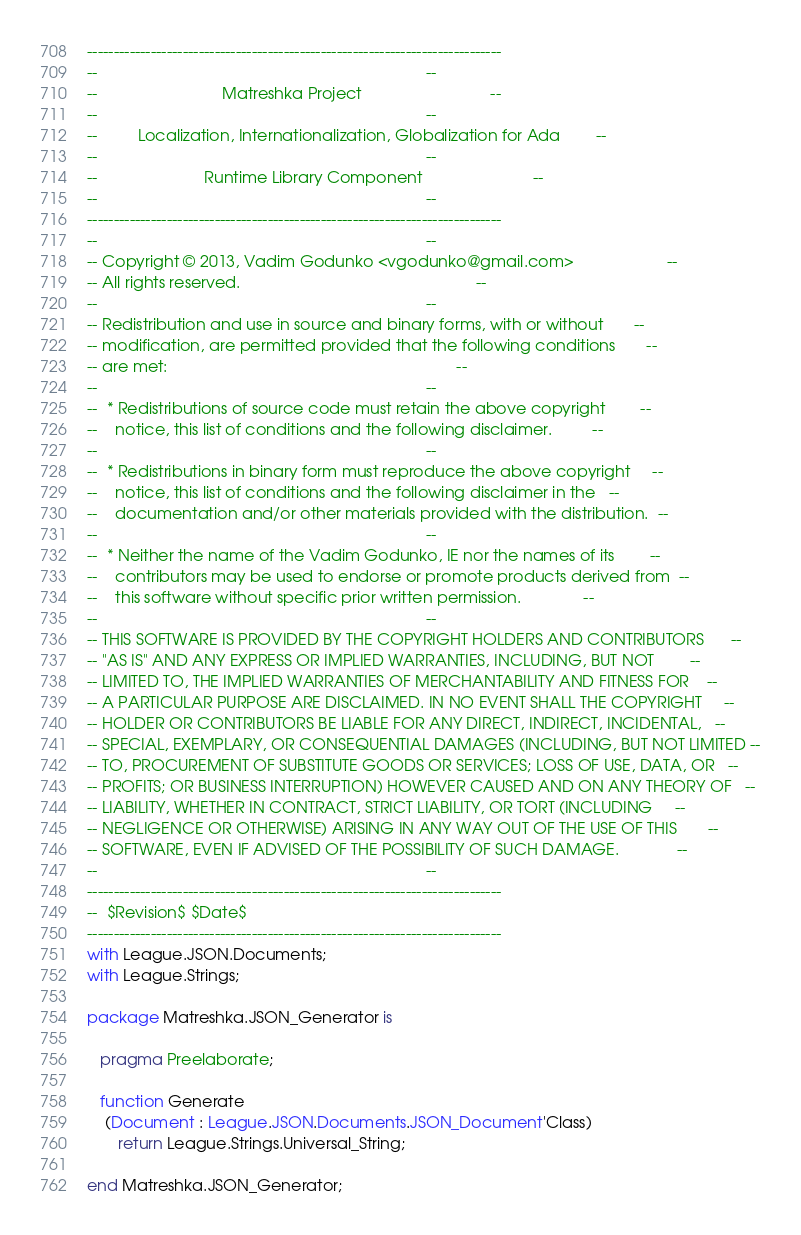<code> <loc_0><loc_0><loc_500><loc_500><_Ada_>------------------------------------------------------------------------------
--                                                                          --
--                            Matreshka Project                             --
--                                                                          --
--         Localization, Internationalization, Globalization for Ada        --
--                                                                          --
--                        Runtime Library Component                         --
--                                                                          --
------------------------------------------------------------------------------
--                                                                          --
-- Copyright © 2013, Vadim Godunko <vgodunko@gmail.com>                     --
-- All rights reserved.                                                     --
--                                                                          --
-- Redistribution and use in source and binary forms, with or without       --
-- modification, are permitted provided that the following conditions       --
-- are met:                                                                 --
--                                                                          --
--  * Redistributions of source code must retain the above copyright        --
--    notice, this list of conditions and the following disclaimer.         --
--                                                                          --
--  * Redistributions in binary form must reproduce the above copyright     --
--    notice, this list of conditions and the following disclaimer in the   --
--    documentation and/or other materials provided with the distribution.  --
--                                                                          --
--  * Neither the name of the Vadim Godunko, IE nor the names of its        --
--    contributors may be used to endorse or promote products derived from  --
--    this software without specific prior written permission.              --
--                                                                          --
-- THIS SOFTWARE IS PROVIDED BY THE COPYRIGHT HOLDERS AND CONTRIBUTORS      --
-- "AS IS" AND ANY EXPRESS OR IMPLIED WARRANTIES, INCLUDING, BUT NOT        --
-- LIMITED TO, THE IMPLIED WARRANTIES OF MERCHANTABILITY AND FITNESS FOR    --
-- A PARTICULAR PURPOSE ARE DISCLAIMED. IN NO EVENT SHALL THE COPYRIGHT     --
-- HOLDER OR CONTRIBUTORS BE LIABLE FOR ANY DIRECT, INDIRECT, INCIDENTAL,   --
-- SPECIAL, EXEMPLARY, OR CONSEQUENTIAL DAMAGES (INCLUDING, BUT NOT LIMITED --
-- TO, PROCUREMENT OF SUBSTITUTE GOODS OR SERVICES; LOSS OF USE, DATA, OR   --
-- PROFITS; OR BUSINESS INTERRUPTION) HOWEVER CAUSED AND ON ANY THEORY OF   --
-- LIABILITY, WHETHER IN CONTRACT, STRICT LIABILITY, OR TORT (INCLUDING     --
-- NEGLIGENCE OR OTHERWISE) ARISING IN ANY WAY OUT OF THE USE OF THIS       --
-- SOFTWARE, EVEN IF ADVISED OF THE POSSIBILITY OF SUCH DAMAGE.             --
--                                                                          --
------------------------------------------------------------------------------
--  $Revision$ $Date$
------------------------------------------------------------------------------
with League.JSON.Documents;
with League.Strings;

package Matreshka.JSON_Generator is

   pragma Preelaborate;

   function Generate
    (Document : League.JSON.Documents.JSON_Document'Class)
       return League.Strings.Universal_String;

end Matreshka.JSON_Generator;
</code> 